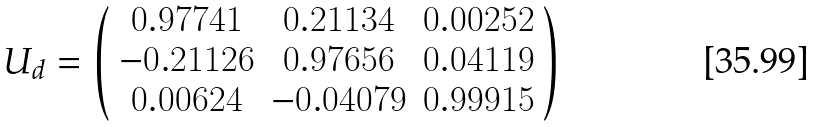Convert formula to latex. <formula><loc_0><loc_0><loc_500><loc_500>U _ { d } = \left ( \begin{array} { c c c } 0 . 9 7 7 4 1 & 0 . 2 1 1 3 4 & 0 . 0 0 2 5 2 \\ - 0 . 2 1 1 2 6 & 0 . 9 7 6 5 6 & 0 . 0 4 1 1 9 \\ 0 . 0 0 6 2 4 & - 0 . 0 4 0 7 9 & 0 . 9 9 9 1 5 \end{array} \right )</formula> 